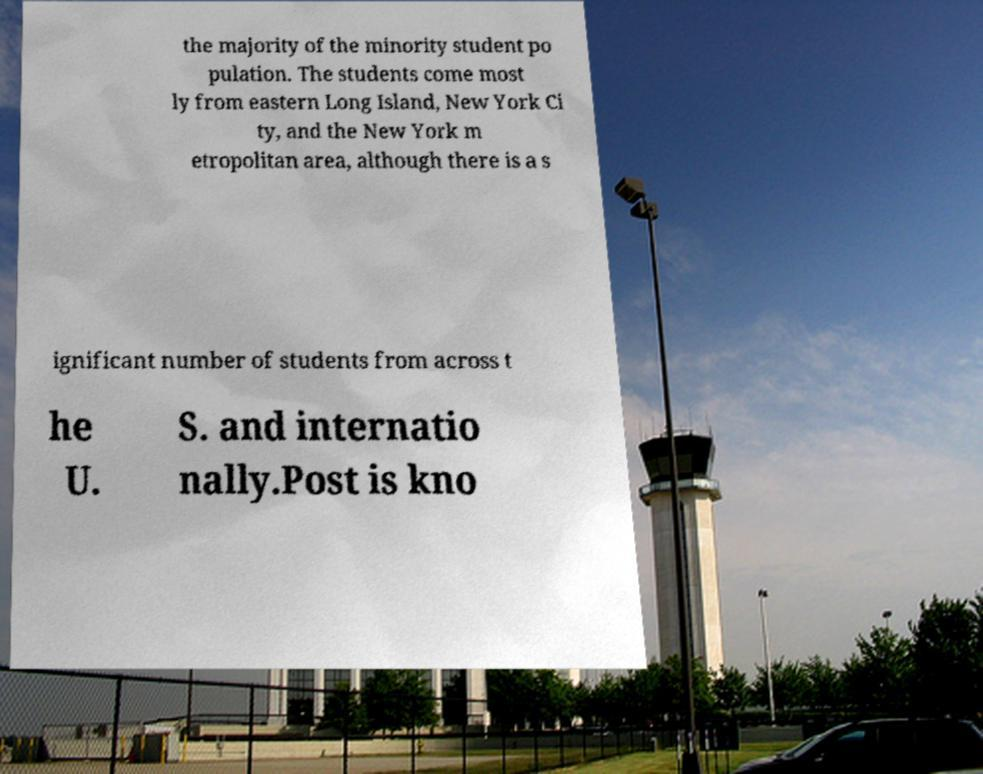For documentation purposes, I need the text within this image transcribed. Could you provide that? the majority of the minority student po pulation. The students come most ly from eastern Long Island, New York Ci ty, and the New York m etropolitan area, although there is a s ignificant number of students from across t he U. S. and internatio nally.Post is kno 